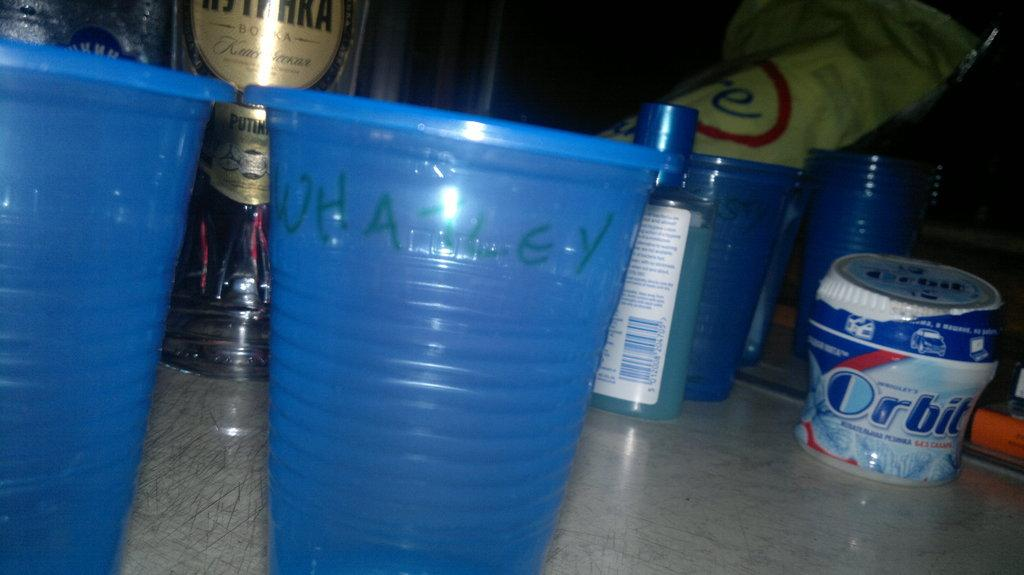<image>
Create a compact narrative representing the image presented. A container of orbit gum sits on a counter top. 